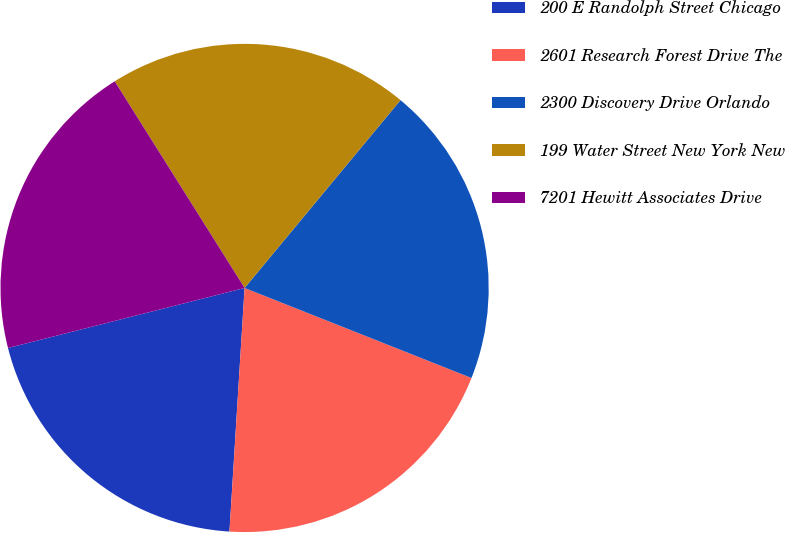Convert chart to OTSL. <chart><loc_0><loc_0><loc_500><loc_500><pie_chart><fcel>200 E Randolph Street Chicago<fcel>2601 Research Forest Drive The<fcel>2300 Discovery Drive Orlando<fcel>199 Water Street New York New<fcel>7201 Hewitt Associates Drive<nl><fcel>20.06%<fcel>19.98%<fcel>19.99%<fcel>19.96%<fcel>20.03%<nl></chart> 